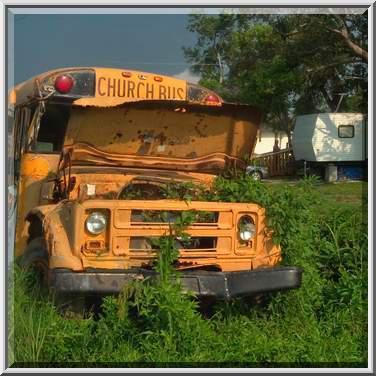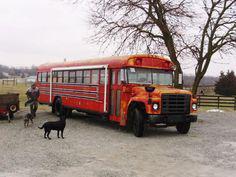The first image is the image on the left, the second image is the image on the right. Considering the images on both sides, is "The right image contains a red-orange bus angled facing rightward." valid? Answer yes or no. Yes. 